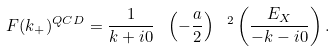<formula> <loc_0><loc_0><loc_500><loc_500>F ( k _ { + } ) ^ { Q C D } = \frac { 1 } { k + i 0 } \ \left ( - \frac { a } { 2 } \right ) \ ^ { 2 } \left ( \frac { E _ { X } } { - k - i 0 } \right ) .</formula> 